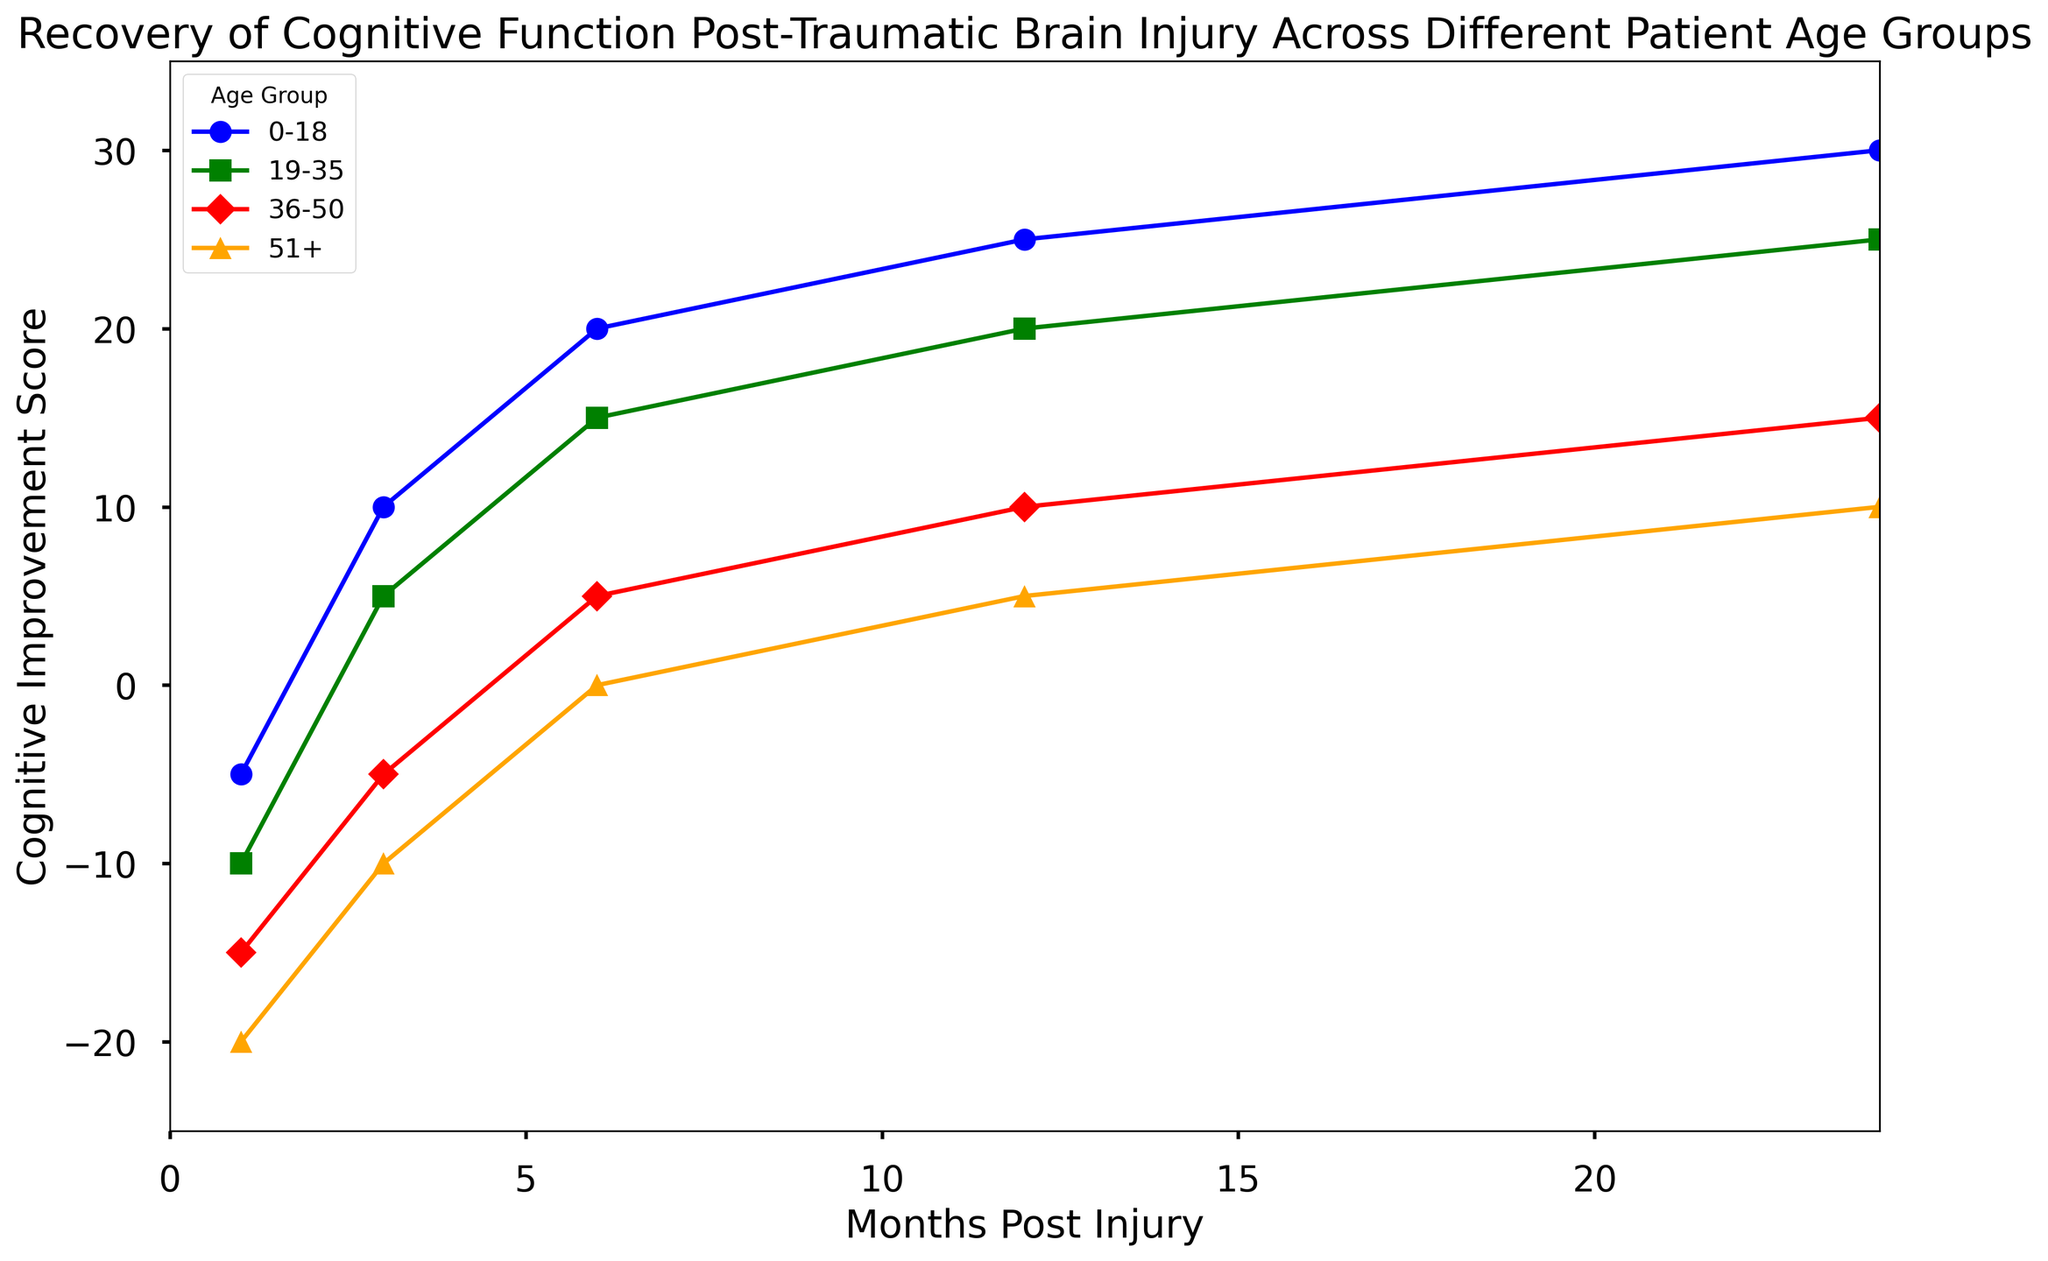What pattern can you observe in the cognitive improvement for patients aged 0-18 months post-injury? The cognitive improvement for patients aged 0-18 first shows a negative score at 1 month post-injury but then improves steadily, with the scores increasing as the months post-injury progress. Specifically, the scores are -5 at 1 month, 10 at 3 months, 20 at 6 months, 25 at 12 months, and 30 at 24 months.
Answer: Steady improvement Which age group shows the least cognitive improvement at 1 month post-injury? At 1 month post-injury, the cognitive improvement scores are -5 for 0-18, -10 for 19-35, -15 for 36-50, and -20 for 51+. Comparing these values, the 51+ age group shows the least cognitive improvement.
Answer: 51+ How does the cognitive improvement score of the 19-35 age group at 12 months post-injury compare to that of the 36-50 age group at the same time point? At 12 months post-injury, the cognitive improvement score for the 19-35 age group is 20, while for the 36-50 age group, it is 10. Therefore, the 19-35 age group has a higher cognitive improvement score at 12 months post-injury.
Answer: 19-35 has higher Which age group has the highest cognitive improvement score at 24 months post-injury? At 24 months post-injury, the scores are 30 for 0-18, 25 for 19-35, 15 for 36-50, and 10 for 51+. The 0-18 age group has the highest cognitive improvement score at this time point.
Answer: 0-18 What is the difference in cognitive improvement scores for the 36-50 age group between 1 month and 6 months post-injury? The cognitive improvement score for the 36-50 age group is -15 at 1 month and 5 at 6 months. The difference is 5 - (-15) = 5 + 15 = 20.
Answer: 20 Which age group shows a consistent positive improvement in cognitive function over 24 months post-injury? The 0-18 age group consistently shows a positive improvement in cognitive function, with scores increasing from -5 at 1 month to 30 at 24 months.
Answer: 0-18 Compare the rate of cognitive improvement between 1 and 3 months post-injury for the 19-35 and 36-50 age groups. Which age group recovers faster in this interval? For 19-35, the score changes from -10 to 5, a difference of 15 points. For 36-50, the score changes from -15 to -5, a difference of 10 points. The 19-35 age group shows a faster rate of recovery between 1 and 3 months.
Answer: 19-35 What is the average cognitive improvement score for the 19-35 age group over the 24-month period? The scores are -10 at 1 month, 5 at 3 months, 15 at 6 months, 20 at 12 months, and 25 at 24 months. The sum is -10 + 5 + 15 + 20 + 25 = 55, and the average is 55 / 5 = 11.
Answer: 11 What is the difference in the cognitive improvement scores between the 0-18 and 51+ age groups at 24 months post-injury? At 24 months post-injury, the scores are 30 for the 0-18 age group and 10 for the 51+ age group. The difference is 30 - 10 = 20.
Answer: 20 